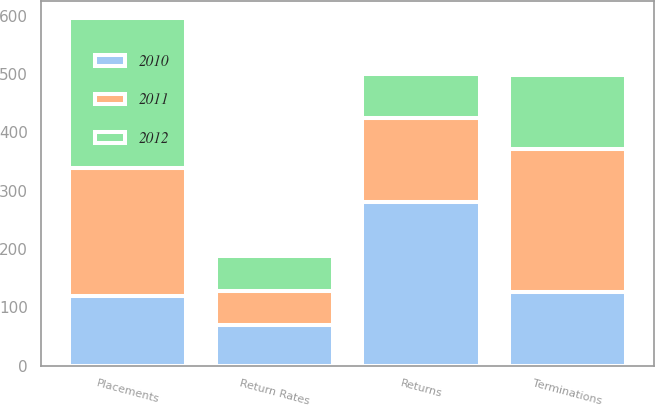<chart> <loc_0><loc_0><loc_500><loc_500><stacked_bar_chart><ecel><fcel>Placements<fcel>Terminations<fcel>Returns<fcel>Return Rates<nl><fcel>2012<fcel>257<fcel>126<fcel>76<fcel>60<nl><fcel>2011<fcel>219<fcel>246<fcel>144<fcel>59<nl><fcel>2010<fcel>120<fcel>126<fcel>281<fcel>69<nl></chart> 